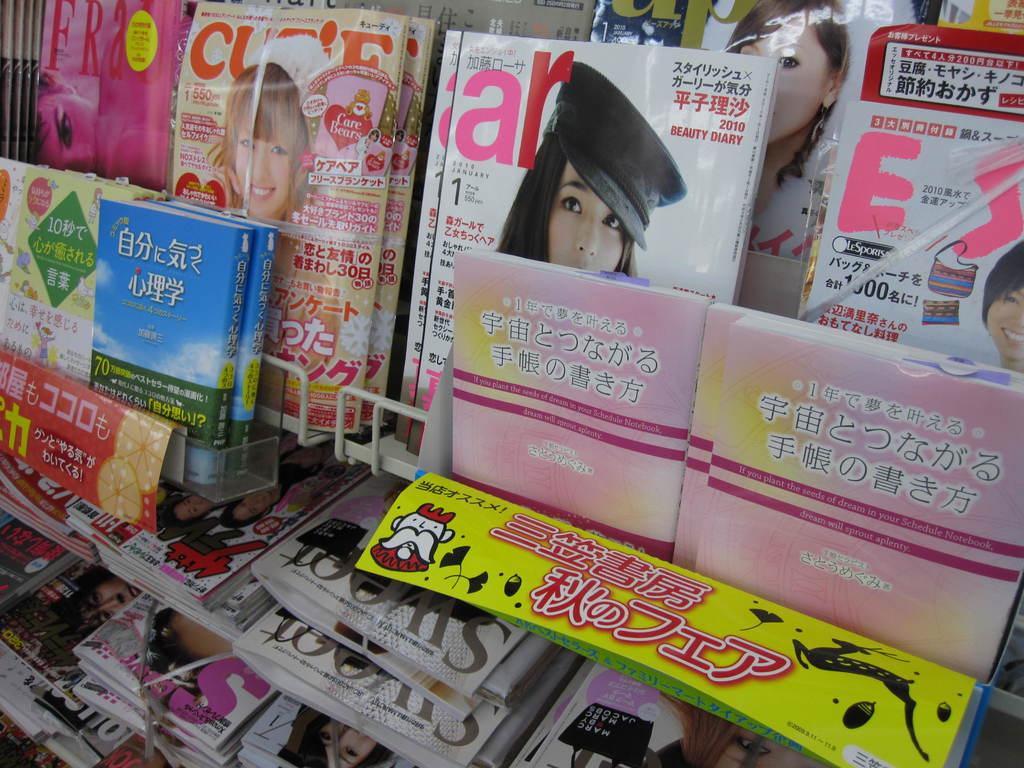Describe this image in one or two sentences. In this picture we can see a few books and magazines in the racks. 